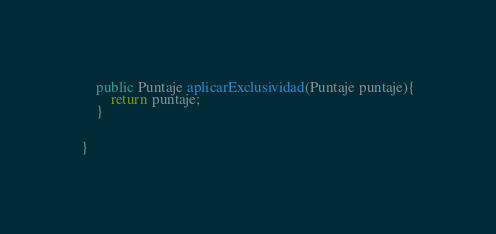Convert code to text. <code><loc_0><loc_0><loc_500><loc_500><_Java_>
    public Puntaje aplicarExclusividad(Puntaje puntaje){
        return puntaje;
    }


}
</code> 